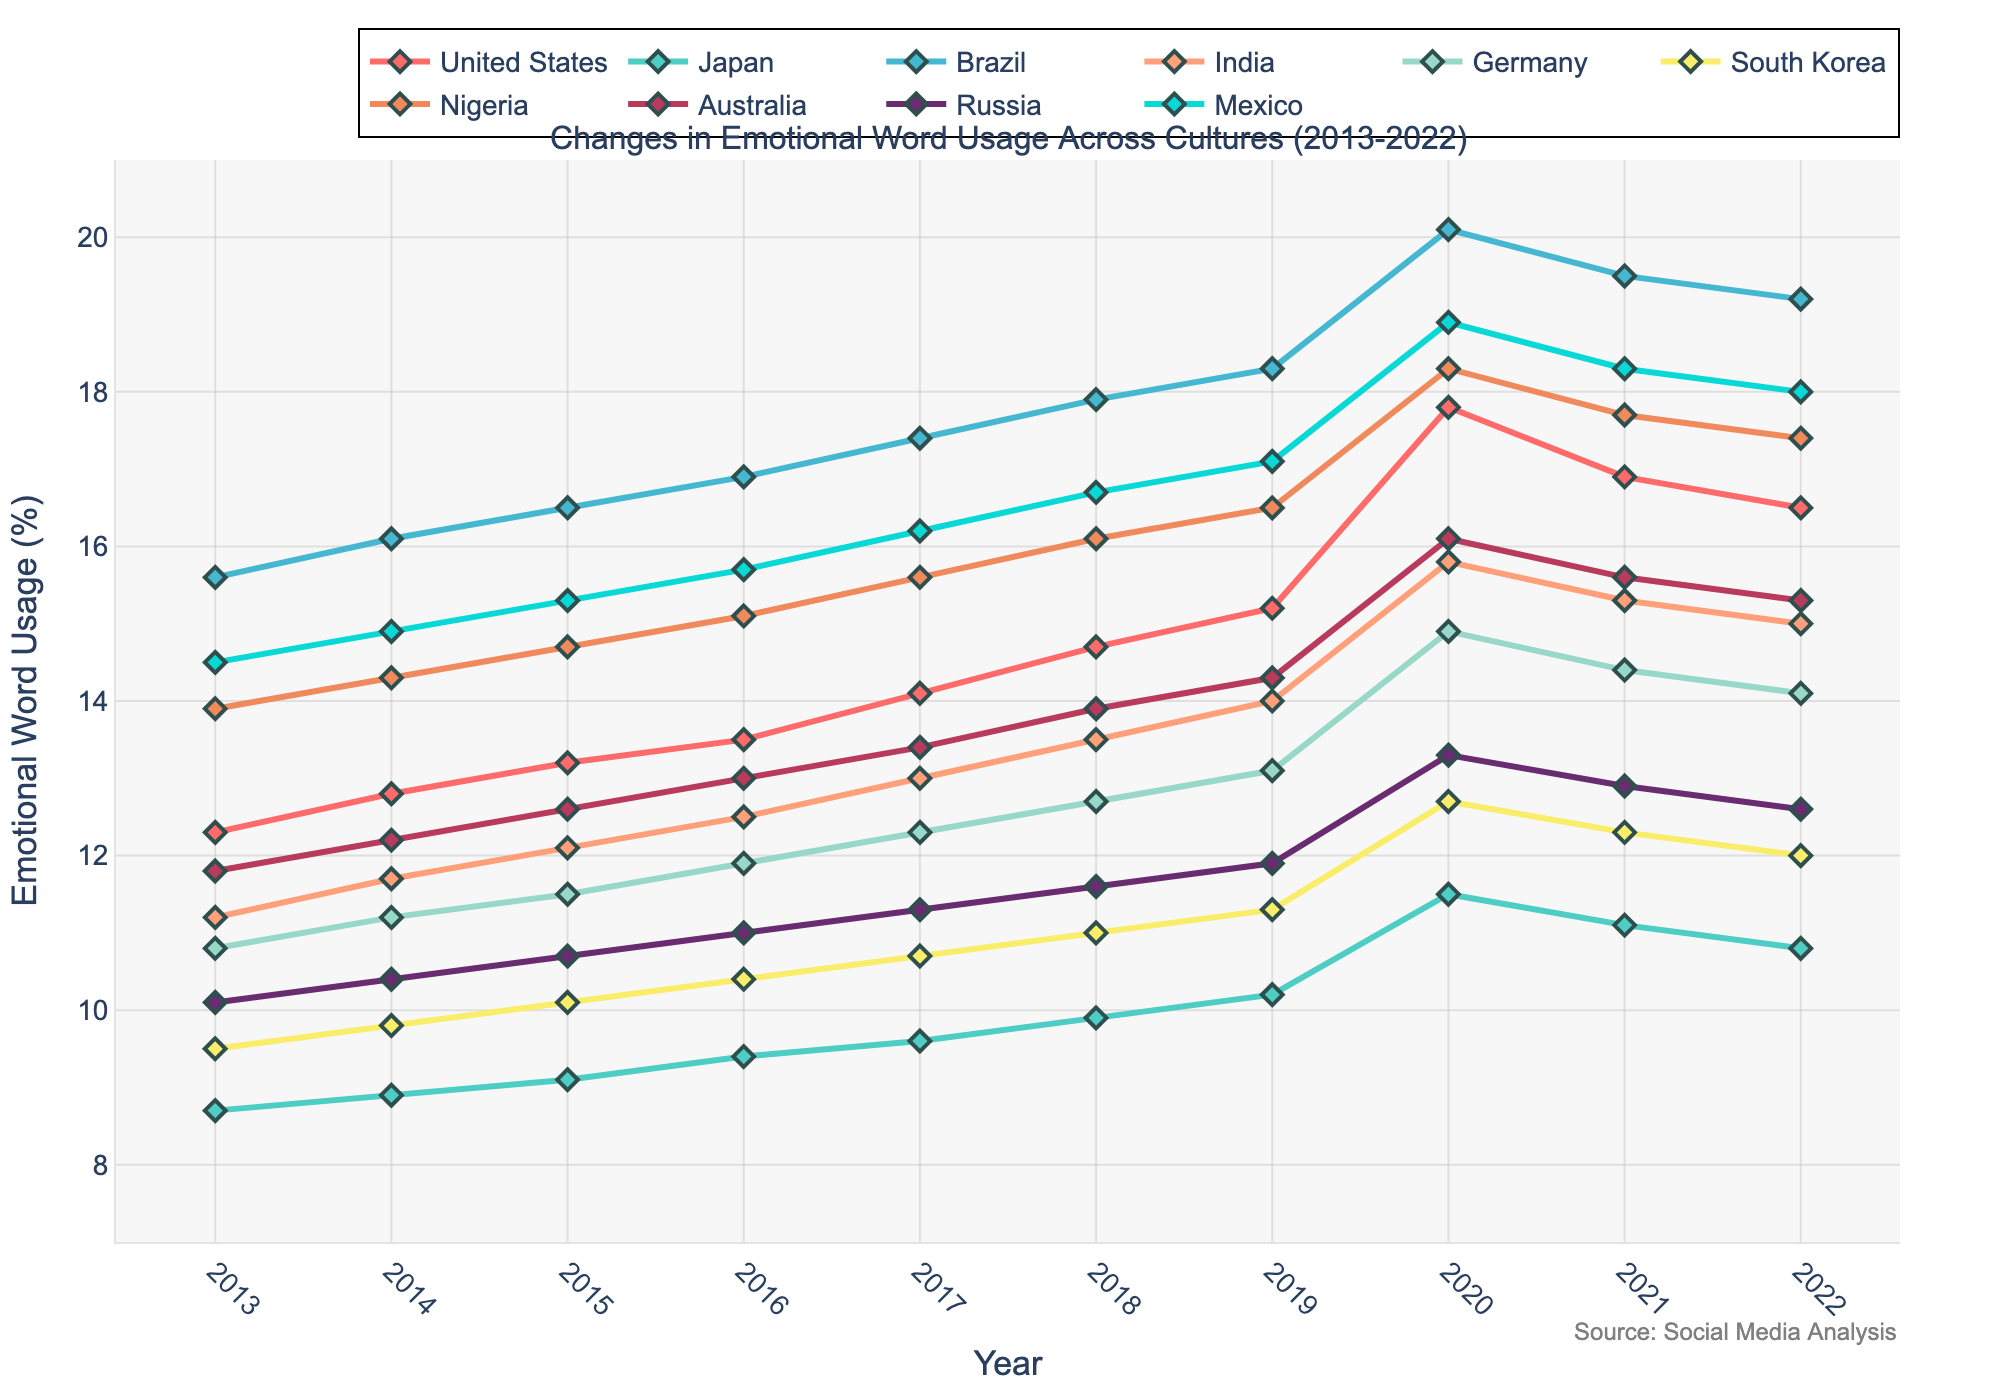What culture showed the highest emotional word usage in 2020? To find the answer, look at the plot for 2020 and see which culture's line reaches the highest value. The highest point corresponds to Brazil.
Answer: Brazil Compare the rate of increase in emotional word usage between the United States and Germany from 2013 to 2022. Which one had a higher increase? Calculate the difference between the 2022 and 2013 values for both the United States and Germany. For the United States, it is 16.5 - 12.3 = 4.2. For Germany, it is 14.1 - 10.8 = 3.3. The United States had a higher increase.
Answer: United States Which cultures had a decrease in emotional word usage from 2020 to 2022? Look at the plot from 2020 to 2022 and identify the cultures whose lines slope downwards. The cultures that show a decrease are the United States, Japan, Brazil, India, Germany, South Korea, Australia, Russia, Mexico, and Nigeria.
Answer: United States, Japan, Brazil, India, Germany, South Korea, Australia, Russia, Mexico, Nigeria What was the average emotional word usage for Mexico over the decade? Add up Mexico's values for each year and divide by the number of years. The sum is 14.5 + 14.9 + 15.3 + 15.7 + 16.2 + 16.7 + 17.1 + 18.9 + 18.3 + 18.0 = 165.6. Divide by 10 to get the average: 165.6 / 10 = 16.56.
Answer: 16.56 How did emotional word usage in Japan change from 2015 to 2018? Look at the values for Japan in the years 2015 and 2018 and calculate the difference. The value for 2015 is 9.1 and for 2018 is 9.9. The change is 9.9 - 9.1 = 0.8.
Answer: Increased by 0.8 Which culture had the most stable emotional word usage over the decade? Compare the changes in emotional word usage for each culture over the decade. The changes for each culture are calculated by subtracting the value of 2013 from 2022. The smallest difference indicates the most stable trend. Japan’s change from 8.7 to 10.8 (a difference of 2.1) is the least among all cultures.
Answer: Japan By how much did Nigeria's emotional word usage increase from 2013 to 2019? Find the difference between Nigeria's 2019 and 2013 values. The value for 2013 is 13.9 and for 2019 is 16.5. The increase is 16.5 - 13.9 = 2.6.
Answer: 2.6 Compare the 2018 emotional word usage between Russia and Australia. Which one had a higher usage? Find the values for Russia and Australia in 2018. For Russia, it is 11.6, and for Australia, it is 13.9. Australia had a higher usage.
Answer: Australia Among all cultures, which one showed the highest emotional word usage in 2017? Identify and compare the values of emotional word usage for each culture in 2017. The highest value corresponds to Brazil with 17.4.
Answer: Brazil How did the emotional word usage trend for South Korea look from 2016 to 2022? Examine the plot to observe how the line for South Korea changes from 2016 to 2022. In 2016, it was 10.4, and it shows a steady increase until around 2020 where it peaks at 12.7, then exhibits a slight decrease to 12.0 in 2022.
Answer: Increasing initially, slight decrease towards the end 